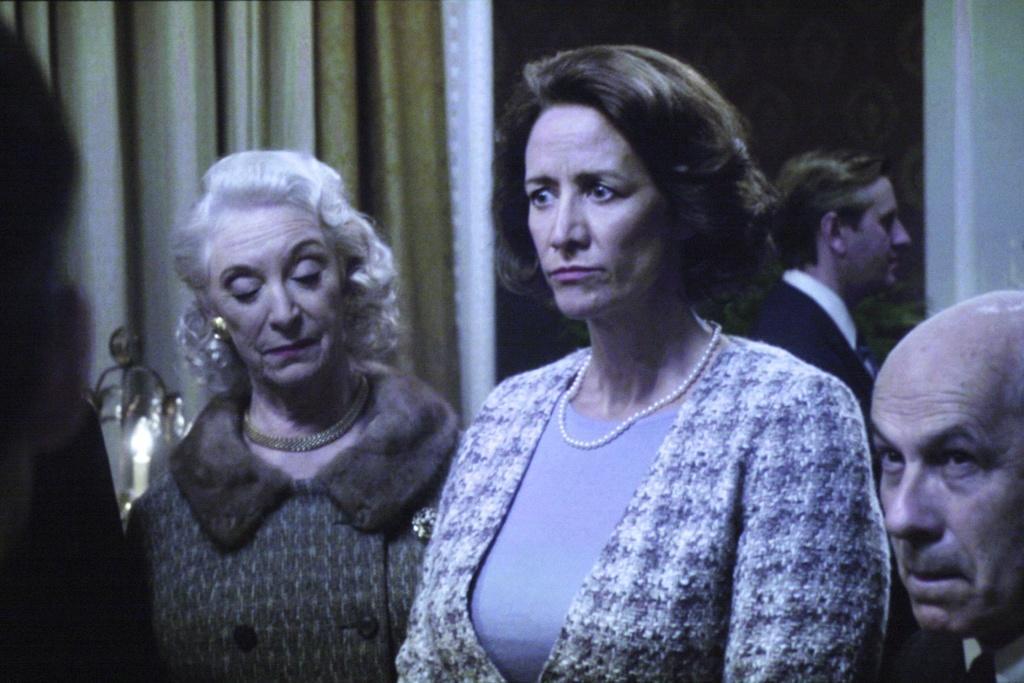Could you give a brief overview of what you see in this image? In this picture there are group of people. At the back there is a curtain and there is a candle and there might be a door. 